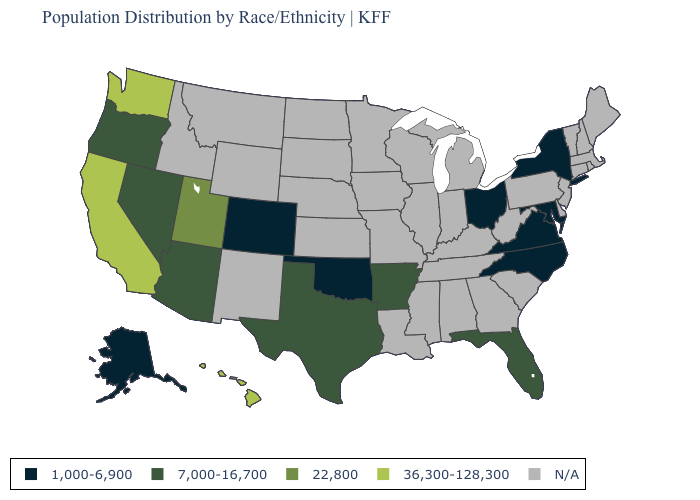What is the highest value in the USA?
Keep it brief. 36,300-128,300. Among the states that border Utah , which have the lowest value?
Keep it brief. Colorado. Which states hav the highest value in the West?
Short answer required. California, Hawaii, Washington. Does the map have missing data?
Be succinct. Yes. What is the value of North Carolina?
Quick response, please. 1,000-6,900. What is the highest value in the South ?
Concise answer only. 7,000-16,700. What is the value of Pennsylvania?
Short answer required. N/A. Name the states that have a value in the range 1,000-6,900?
Give a very brief answer. Alaska, Colorado, Maryland, New York, North Carolina, Ohio, Oklahoma, Virginia. What is the value of Alaska?
Keep it brief. 1,000-6,900. Which states hav the highest value in the Northeast?
Short answer required. New York. Name the states that have a value in the range N/A?
Short answer required. Alabama, Connecticut, Delaware, Georgia, Idaho, Illinois, Indiana, Iowa, Kansas, Kentucky, Louisiana, Maine, Massachusetts, Michigan, Minnesota, Mississippi, Missouri, Montana, Nebraska, New Hampshire, New Jersey, New Mexico, North Dakota, Pennsylvania, Rhode Island, South Carolina, South Dakota, Tennessee, Vermont, West Virginia, Wisconsin, Wyoming. What is the highest value in the West ?
Keep it brief. 36,300-128,300. Name the states that have a value in the range 22,800?
Answer briefly. Utah. Name the states that have a value in the range 22,800?
Quick response, please. Utah. 